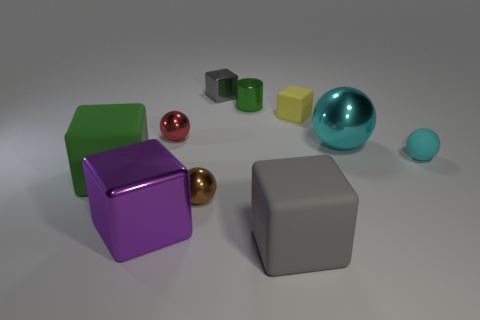Is the color of the big object behind the cyan matte thing the same as the matte sphere?
Give a very brief answer. Yes. Is there any other thing of the same color as the large metal ball?
Your answer should be very brief. Yes. What color is the big shiny thing that is on the right side of the gray cube that is in front of the tiny cylinder?
Provide a short and direct response. Cyan. Does the small yellow object have the same shape as the green object in front of the metal cylinder?
Provide a short and direct response. Yes. What is the material of the gray thing that is behind the green object that is to the left of the large metal object in front of the large green cube?
Make the answer very short. Metal. Are there any other shiny blocks of the same size as the purple shiny block?
Your response must be concise. No. What is the size of the gray block that is made of the same material as the small green cylinder?
Keep it short and to the point. Small. What is the shape of the small green metal thing?
Provide a succinct answer. Cylinder. Does the green cylinder have the same material as the tiny gray thing that is behind the green rubber object?
Give a very brief answer. Yes. What number of objects are either large gray objects or rubber balls?
Your response must be concise. 2. 